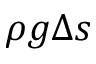Convert formula to latex. <formula><loc_0><loc_0><loc_500><loc_500>\rho g \Delta s</formula> 